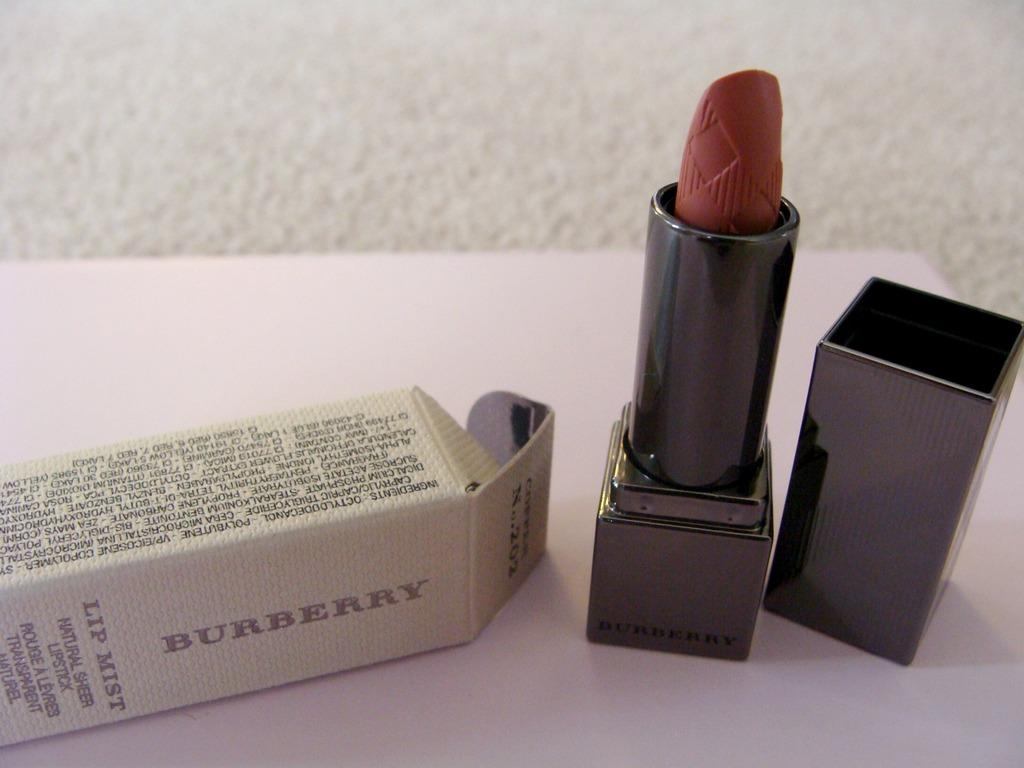<image>
Give a short and clear explanation of the subsequent image. Unused Burberry Lip Mist lip stick positioned next to it's original packaging. 